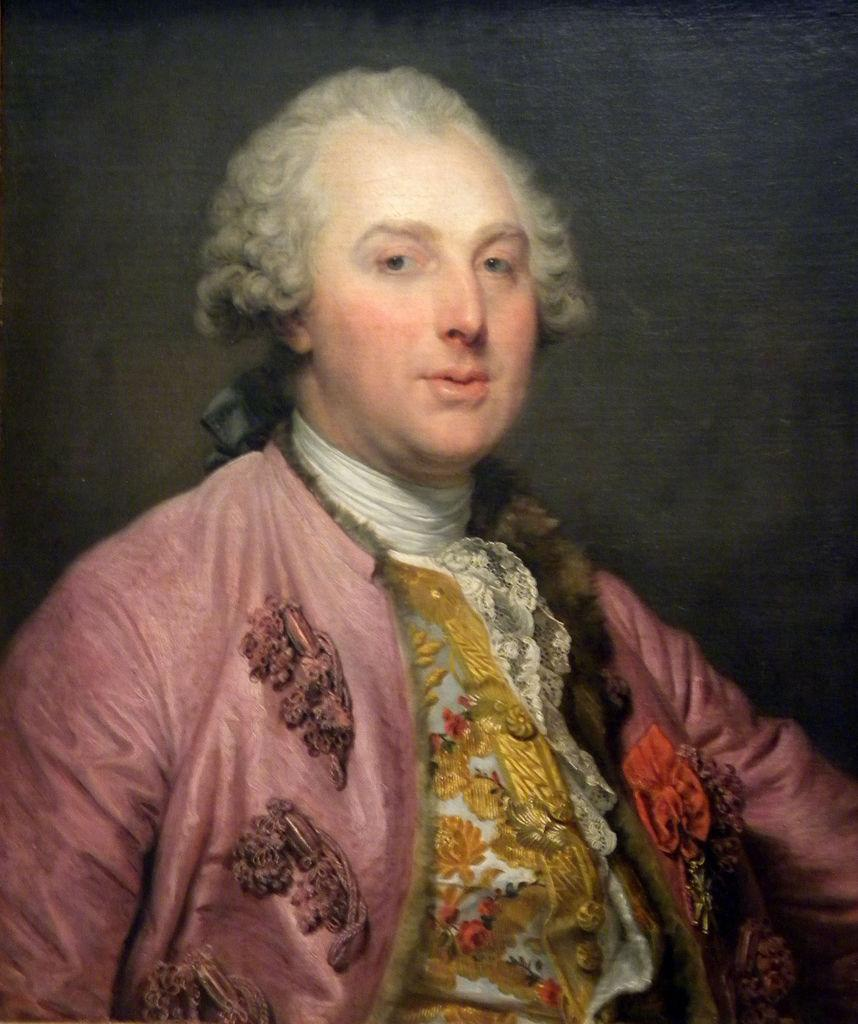What is the main subject of the image? There is a person in the image. Can you describe the person's appearance? The person is wearing colorful clothes and has curly hair. What type of credit card does the person have in their hand in the image? There is no credit card or any indication of financial transactions in the image. What is the girl doing in the image? The provided facts do not mention a girl in the image, only a person. 